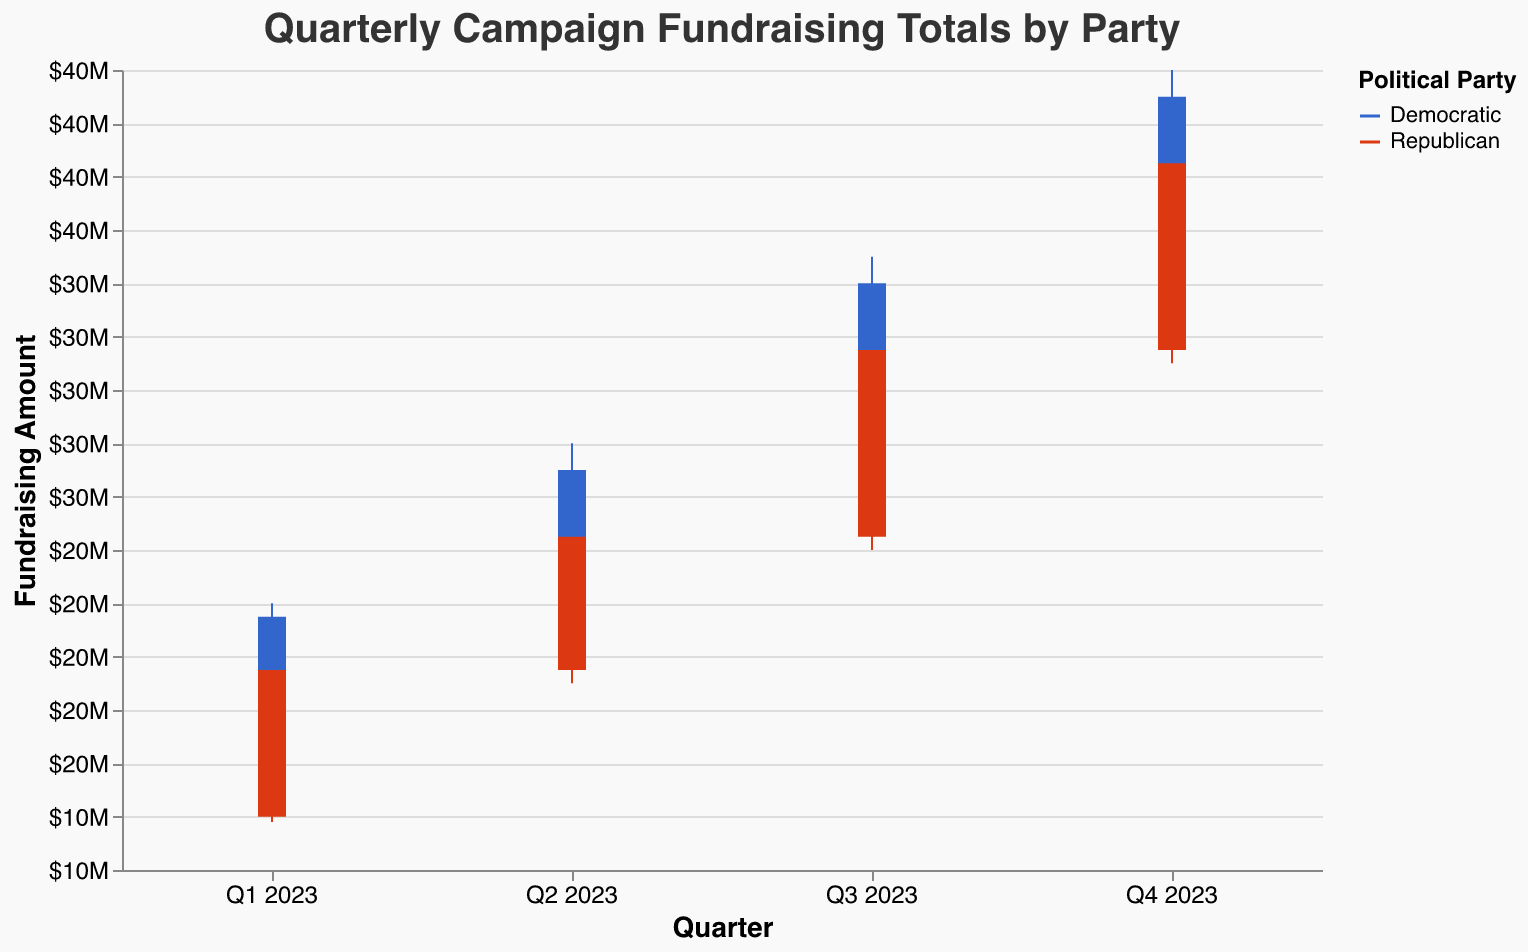What is the title of the figure? The title of the figure is prominently displayed at the top of the chart. It reads "Quarterly Campaign Fundraising Totals by Party."
Answer: Quarterly Campaign Fundraising Totals by Party What are the colors used to represent the Democratic and Republican parties? Each party is represented by a different color on the chart. The Democratic Party is shown in blue, and the Republican Party is shown in red.
Answer: Blue for Democratic, Red for Republican In which quarter did the Democratic Party raise the most funds by the end of the quarter? To find the quarter with the highest funds raised by the Democratic Party, look at the "Close" values for each quarter. The highest close value for the Democratic Party is in Q4 2023 with $41,000,000.
Answer: Q4 2023 Compare the fundraising range (difference between High and Low) for the Democratic Party and the Republican Party in Q3 2023. Which party had a larger range? The fundraising range can be calculated by subtracting the Low value from the High value. For the Democratic Party in Q3 2023, it's $35,000,000 - $26,500,000 = $8,500,000. For the Republican Party in Q3 2023, it's $32,000,000 - $24,000,000 = $8,000,000. Thus, the Democratic Party had a larger range.
Answer: Democratic Party What is the average "Open" value for the Republican Party across all quarters? To find the average "Open" value, sum all the "Open" values for the Republican Party and divide by the number of quarters. The "Open" values are $14,000,000, $19,500,000, $24,500,000, and $31,500,000. The sum is $89,500,000. Dividing this by 4 gives an average of $22,375,000.
Answer: $22,375,000 In Q2 2023, did the Democratic Party or the Republican Party have a higher "High" value, and by how much? To determine which party had a higher "High" value, compare the figures: $28,000,000 (Democratic) vs. $25,000,000 (Republican). The Democratic Party had a higher value by $3,000,000.
Answer: Democratic Party, $3,000,000 Which quarter shows the smallest difference between the "Open" and "Close" values for the Republican Party? Calculate the difference between the "Open" and "Close" values for the Republican Party for each quarter. Q1 2023: $19,500,000 - $14,000,000 = $5,500,000. Q2 2023: $24,500,000 - $19,500,000 = $5,000,000. Q3 2023: $31,500,000 - $24,500,000 = $7,000,000. Q4 2023: $38,500,000 - $31,500,000 = $7,000,000. The smallest difference is in Q2 2023, with $5,000,000.
Answer: Q2 2023 What is the total fundraising amount (using Close values) for both parties combined in Q4 2023? Add the "Close" values for both parties in Q4 2023: $41,000,000 (Democratic) + $38,500,000 (Republican) = $79,500,000.
Answer: $79,500,000 Which party had a higher "Low" value in Q1 2023? Compare the "Low" values for both parties in Q1 2023. The Democratic Party had a "Low" value of $14,500,000, whereas the Republican Party had a "Low" value of $13,800,000. Thus, the Democratic Party had a higher "Low" value.
Answer: Democratic Party Did any party have an "Open" value larger than a "High" value of the previous quarter? Reviewing the data: For the Republican Party from Q1 to Q2 2023, the "Open" value of Q2 ($19,500,000) is less than the "High" value of Q1 ($20,000,000). For the Democratic Party from Q1 to Q2 2023, the "Open" value of Q2 ($21,500,000) is less than the "High" value of Q1 ($22,000,000). No party's "Open" value of a quarter was larger than the "High" value of the previous quarter.
Answer: No 